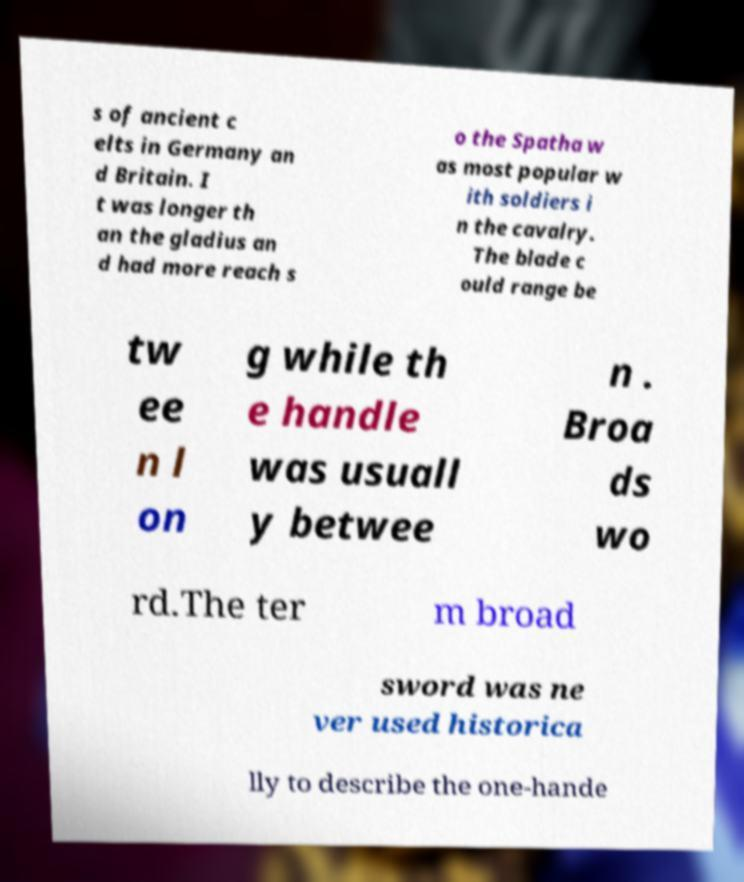Please read and relay the text visible in this image. What does it say? s of ancient c elts in Germany an d Britain. I t was longer th an the gladius an d had more reach s o the Spatha w as most popular w ith soldiers i n the cavalry. The blade c ould range be tw ee n l on g while th e handle was usuall y betwee n . Broa ds wo rd.The ter m broad sword was ne ver used historica lly to describe the one-hande 